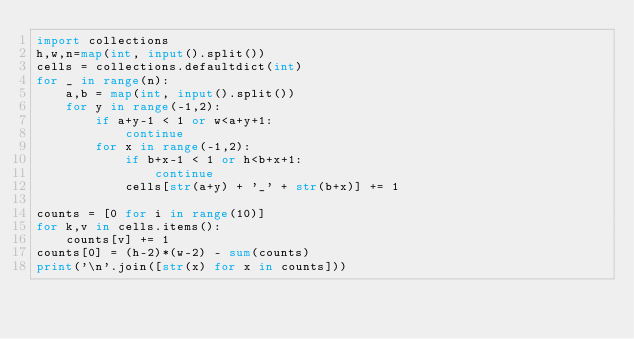<code> <loc_0><loc_0><loc_500><loc_500><_Python_>import collections
h,w,n=map(int, input().split())
cells = collections.defaultdict(int)
for _ in range(n):
    a,b = map(int, input().split())
    for y in range(-1,2):
        if a+y-1 < 1 or w<a+y+1:
            continue
        for x in range(-1,2):
            if b+x-1 < 1 or h<b+x+1:
                continue
            cells[str(a+y) + '_' + str(b+x)] += 1

counts = [0 for i in range(10)]
for k,v in cells.items():
    counts[v] += 1
counts[0] = (h-2)*(w-2) - sum(counts)
print('\n'.join([str(x) for x in counts]))


</code> 